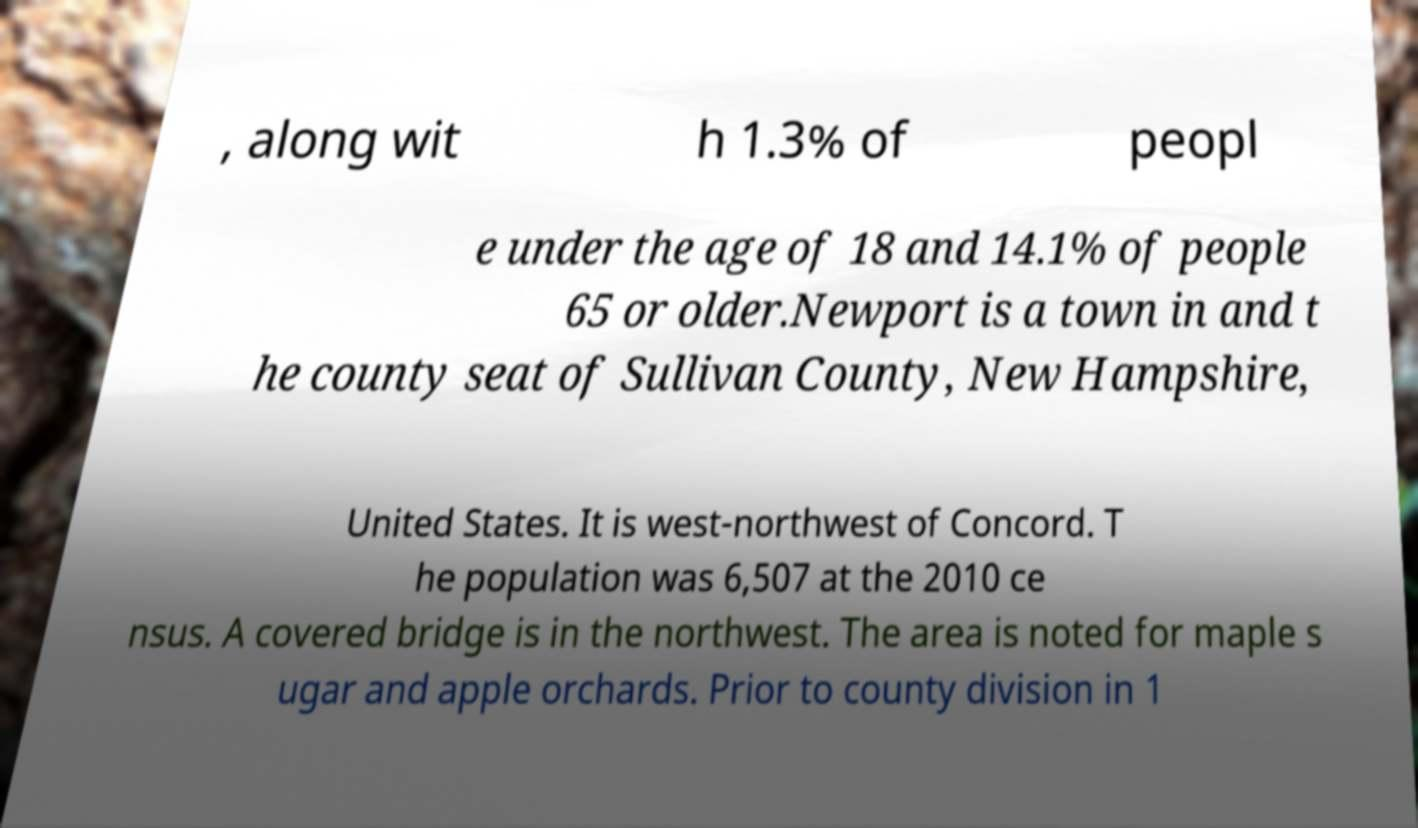Please identify and transcribe the text found in this image. , along wit h 1.3% of peopl e under the age of 18 and 14.1% of people 65 or older.Newport is a town in and t he county seat of Sullivan County, New Hampshire, United States. It is west-northwest of Concord. T he population was 6,507 at the 2010 ce nsus. A covered bridge is in the northwest. The area is noted for maple s ugar and apple orchards. Prior to county division in 1 